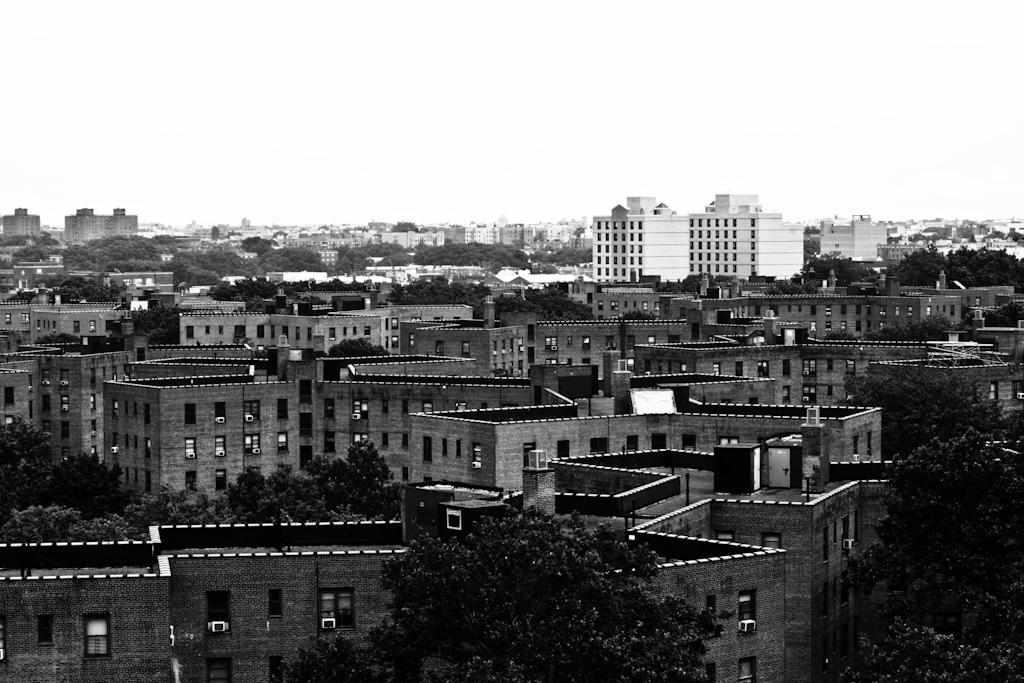What is the color scheme of the image? The image is black and white. What type of natural elements can be seen in the image? There are many trees in the image. What type of structures are present in the image? There are buildings with windows in the image. What additional features can be seen on the buildings? The buildings have AC units. What is visible in the background of the image? The sky is visible in the background of the image. What religion is being practiced in the image? There is no indication of any religious practice in the image. What class of people is depicted in the image? The image does not depict any specific class of people; it primarily features trees, buildings, and the sky. 